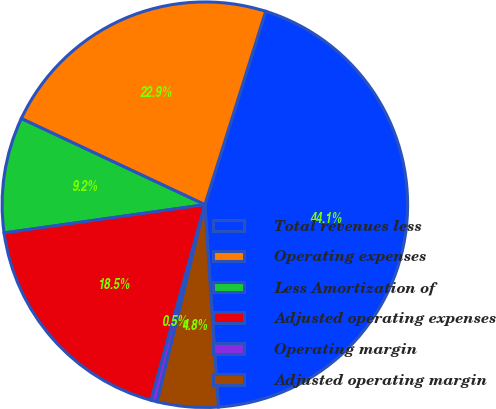Convert chart. <chart><loc_0><loc_0><loc_500><loc_500><pie_chart><fcel>Total revenues less<fcel>Operating expenses<fcel>Less Amortization of<fcel>Adjusted operating expenses<fcel>Operating margin<fcel>Adjusted operating margin<nl><fcel>44.09%<fcel>22.87%<fcel>9.21%<fcel>18.51%<fcel>0.48%<fcel>4.85%<nl></chart> 